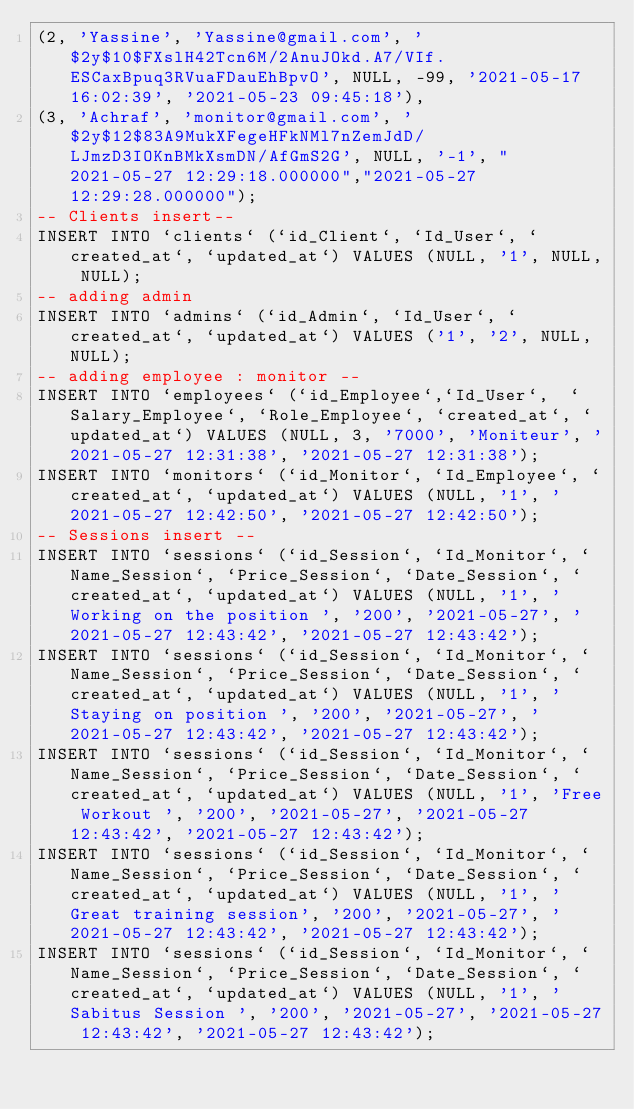Convert code to text. <code><loc_0><loc_0><loc_500><loc_500><_SQL_>(2, 'Yassine', 'Yassine@gmail.com', '$2y$10$FXslH42Tcn6M/2AnuJOkd.A7/VIf.ESCaxBpuq3RVuaFDauEhBpvO', NULL, -99, '2021-05-17 16:02:39', '2021-05-23 09:45:18'),
(3, 'Achraf', 'monitor@gmail.com', '$2y$12$83A9MukXFegeHFkNMl7nZemJdD/LJmzD3IOKnBMkXsmDN/AfGmS2G', NULL, '-1', "2021-05-27 12:29:18.000000","2021-05-27 12:29:28.000000");
-- Clients insert--
INSERT INTO `clients` (`id_Client`, `Id_User`, `created_at`, `updated_at`) VALUES (NULL, '1', NULL, NULL);
-- adding admin
INSERT INTO `admins` (`id_Admin`, `Id_User`, `created_at`, `updated_at`) VALUES ('1', '2', NULL, NULL);
-- adding employee : monitor --
INSERT INTO `employees` (`id_Employee`,`Id_User`,  `Salary_Employee`, `Role_Employee`, `created_at`, `updated_at`) VALUES (NULL, 3, '7000', 'Moniteur', '2021-05-27 12:31:38', '2021-05-27 12:31:38');
INSERT INTO `monitors` (`id_Monitor`, `Id_Employee`, `created_at`, `updated_at`) VALUES (NULL, '1', '2021-05-27 12:42:50', '2021-05-27 12:42:50');
-- Sessions insert --
INSERT INTO `sessions` (`id_Session`, `Id_Monitor`, `Name_Session`, `Price_Session`, `Date_Session`, `created_at`, `updated_at`) VALUES (NULL, '1', 'Working on the position ', '200', '2021-05-27', '2021-05-27 12:43:42', '2021-05-27 12:43:42');
INSERT INTO `sessions` (`id_Session`, `Id_Monitor`, `Name_Session`, `Price_Session`, `Date_Session`, `created_at`, `updated_at`) VALUES (NULL, '1', 'Staying on position ', '200', '2021-05-27', '2021-05-27 12:43:42', '2021-05-27 12:43:42');
INSERT INTO `sessions` (`id_Session`, `Id_Monitor`, `Name_Session`, `Price_Session`, `Date_Session`, `created_at`, `updated_at`) VALUES (NULL, '1', 'Free Workout ', '200', '2021-05-27', '2021-05-27 12:43:42', '2021-05-27 12:43:42');
INSERT INTO `sessions` (`id_Session`, `Id_Monitor`, `Name_Session`, `Price_Session`, `Date_Session`, `created_at`, `updated_at`) VALUES (NULL, '1', 'Great training session', '200', '2021-05-27', '2021-05-27 12:43:42', '2021-05-27 12:43:42');
INSERT INTO `sessions` (`id_Session`, `Id_Monitor`, `Name_Session`, `Price_Session`, `Date_Session`, `created_at`, `updated_at`) VALUES (NULL, '1', 'Sabitus Session ', '200', '2021-05-27', '2021-05-27 12:43:42', '2021-05-27 12:43:42');</code> 